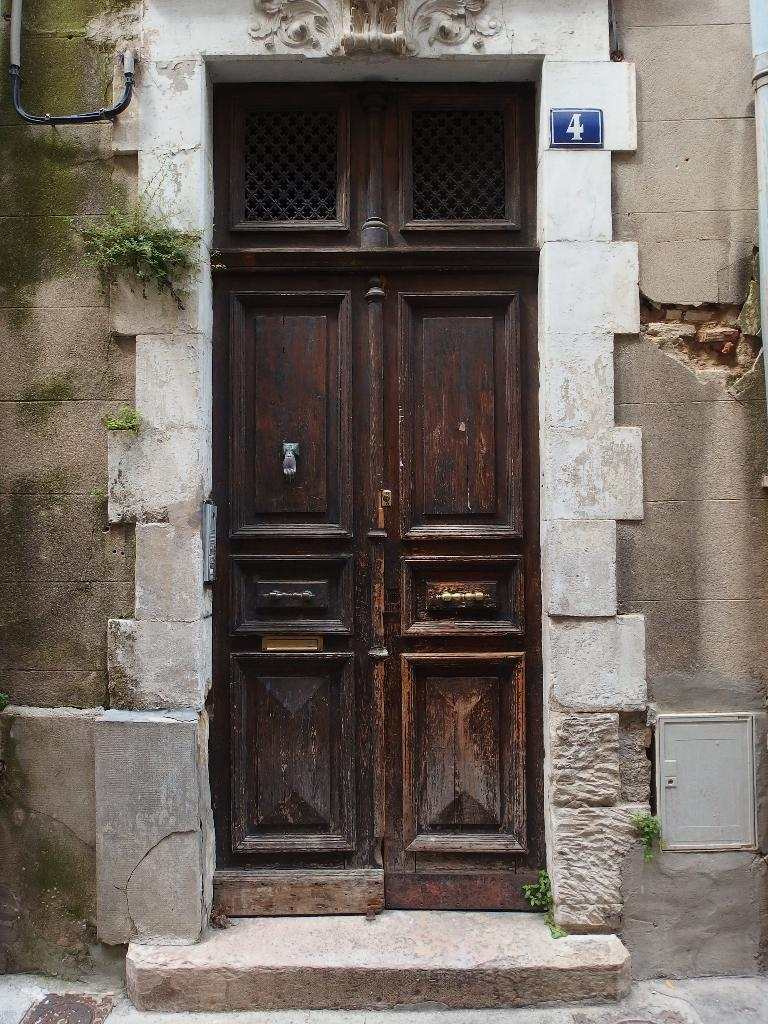What is the main structure visible in the image? There is a wall with a door in the image. Are there any decorative elements on the wall? Yes, there is a plant on the wall in the image. What is the primary focus of the bottom part of the image? The bottom of the image features a wall. How does the plant make its payment for being on the wall? The image does not show any indication of payment, and plants do not have the ability to make payments. 